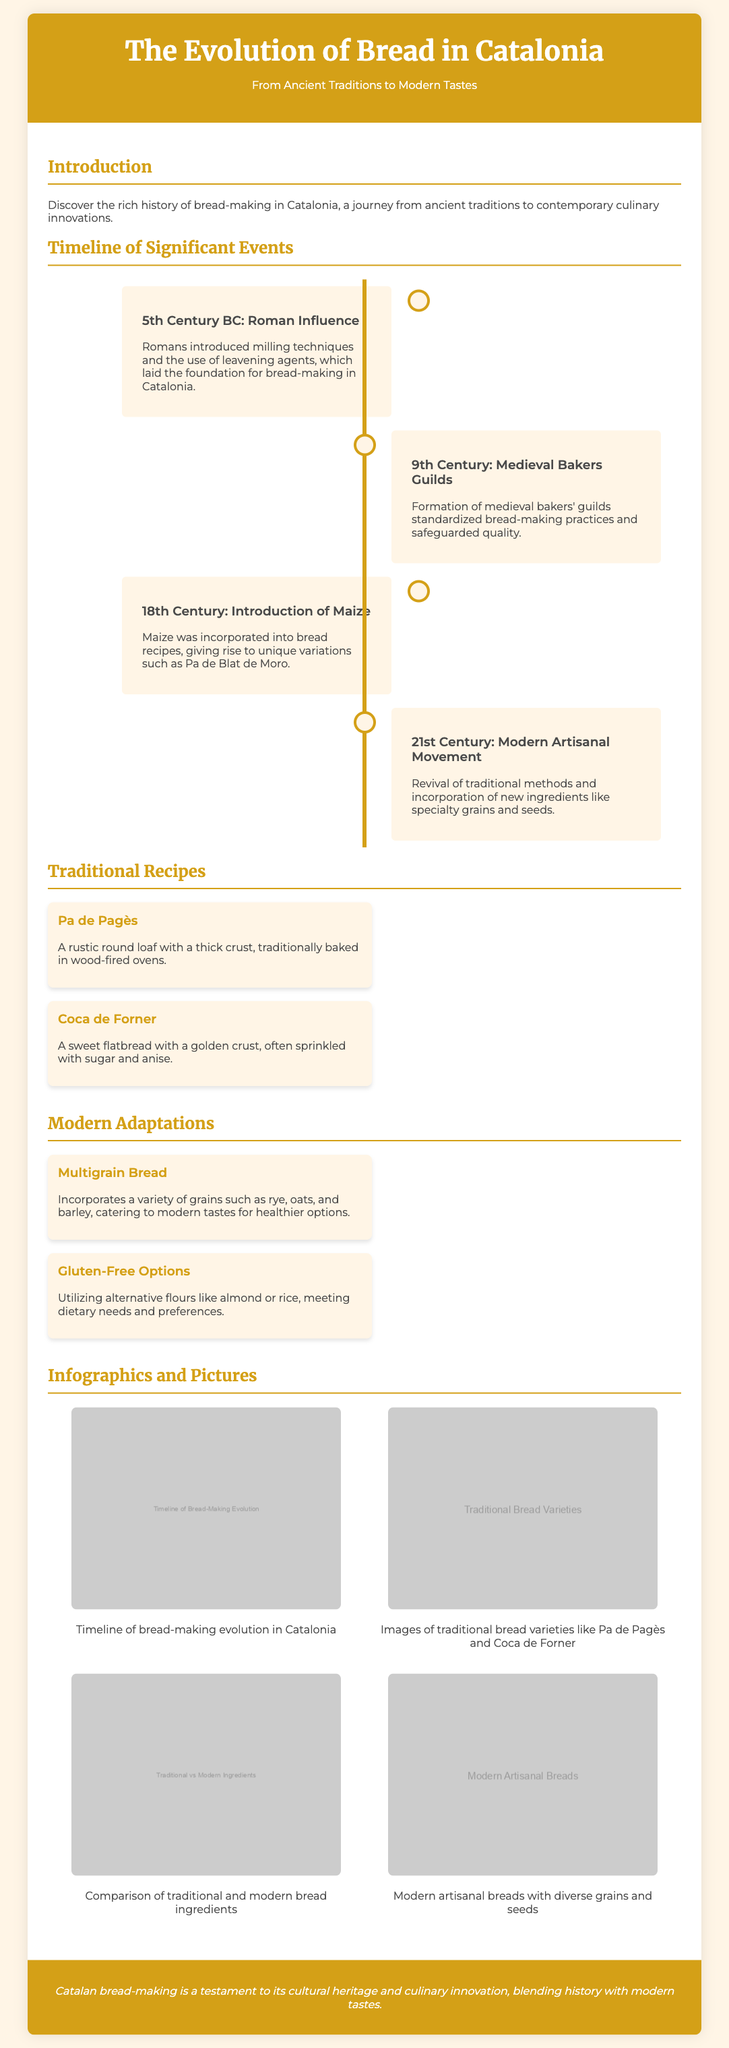What century saw the introduction of maize into bread recipes? The document states that maize was introduced in the 18th century, marking a significant development in regional bread-making practices.
Answer: 18th Century What is the name of the rustic round loaf mentioned in traditional recipes? The rustic round loaf is referred to as "Pa de Pagès" in the document.
Answer: Pa de Pagès Which innovative movement began in the 21st century according to the timeline? The document highlights the modern artisanal movement as a significant evolution in bread-making from the 21st century.
Answer: Modern Artisanal Movement What are the two types of modern adaptations listed? The document specifies two modern adaptations: multigrain bread and gluten-free options.
Answer: Multigrain Bread and Gluten-Free Options What significant influence did the Romans have on bread-making? It is stated that the Romans introduced milling techniques and leavening agents, foundational to bread-making in Catalonia.
Answer: Milling techniques and leavening agents What is the main theme of the flyer? The main theme of the flyer is the evolution of bread in Catalonia, covering its historical and modern aspects.
Answer: The Evolution of Bread in Catalonia What color is prominently featured in the header of the document? The header color is described as #D4A017, which is a golden shade.
Answer: Golden Which traditional bread is noted for its sweetness and anise flavor? The document identifies "Coca de Forner" as the traditional sweet flatbread flavored with anise.
Answer: Coca de Forner What visual elements are included in the infographics section? The infographics section includes images comparing traditional and modern bread ingredients, as well as showcasing different bread types.
Answer: Images of traditional and modern bread ingredients 